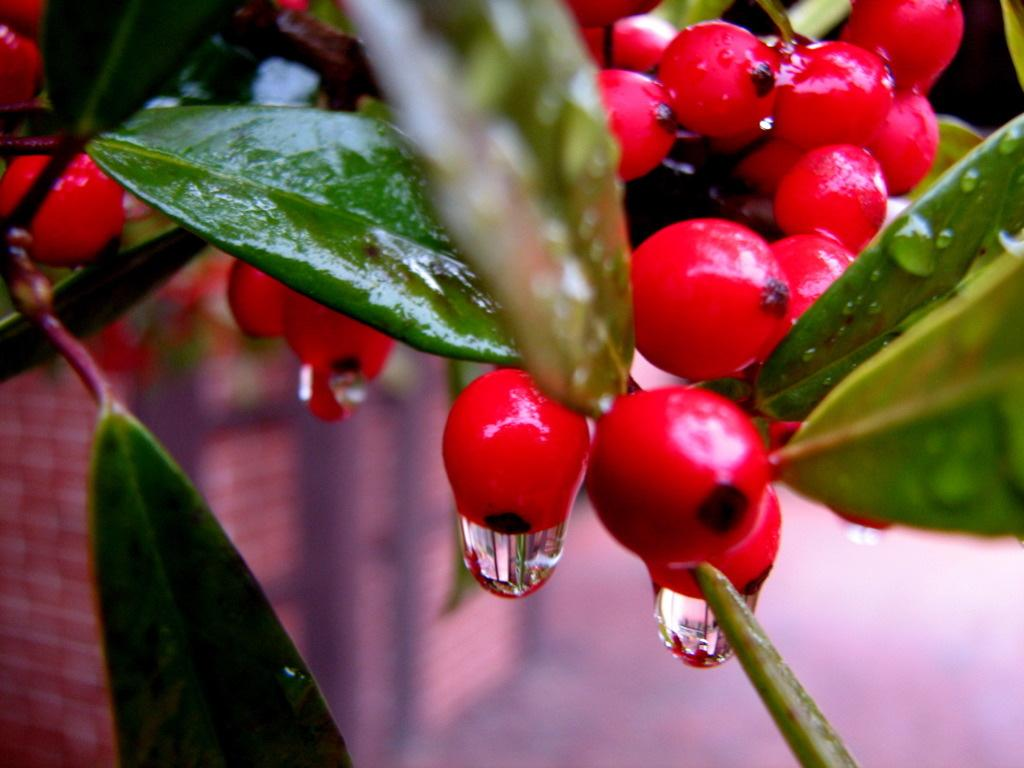What type of plant is in the image? There is a plant in the image, but the specific type cannot be determined from the facts provided. What features can be observed on the plant? The plant has leaves and red color fruits. What is the condition of the plant in the image? There are water drops visible on the plant or its surroundings. What is the background of the plant in the image? There is a wall under the plant, but it is not clearly visible. What type of mask is the plant wearing in the image? There is no mask present on the plant in the image. Is the plant poisonous, as indicated by the red color fruits? The red color of the fruits does not necessarily indicate that the plant is poisonous; it could simply be a characteristic of the plant's appearance. 